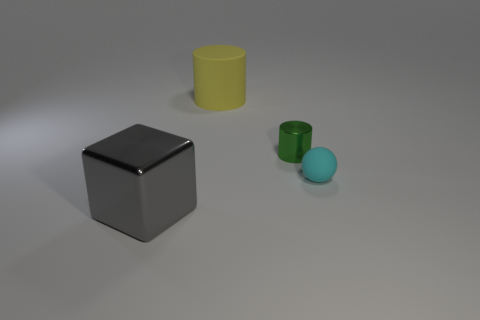Add 1 big yellow matte cylinders. How many objects exist? 5 Subtract all cubes. How many objects are left? 3 Add 4 yellow matte cylinders. How many yellow matte cylinders are left? 5 Add 2 large purple rubber cylinders. How many large purple rubber cylinders exist? 2 Subtract 0 blue balls. How many objects are left? 4 Subtract all tiny purple cylinders. Subtract all green shiny objects. How many objects are left? 3 